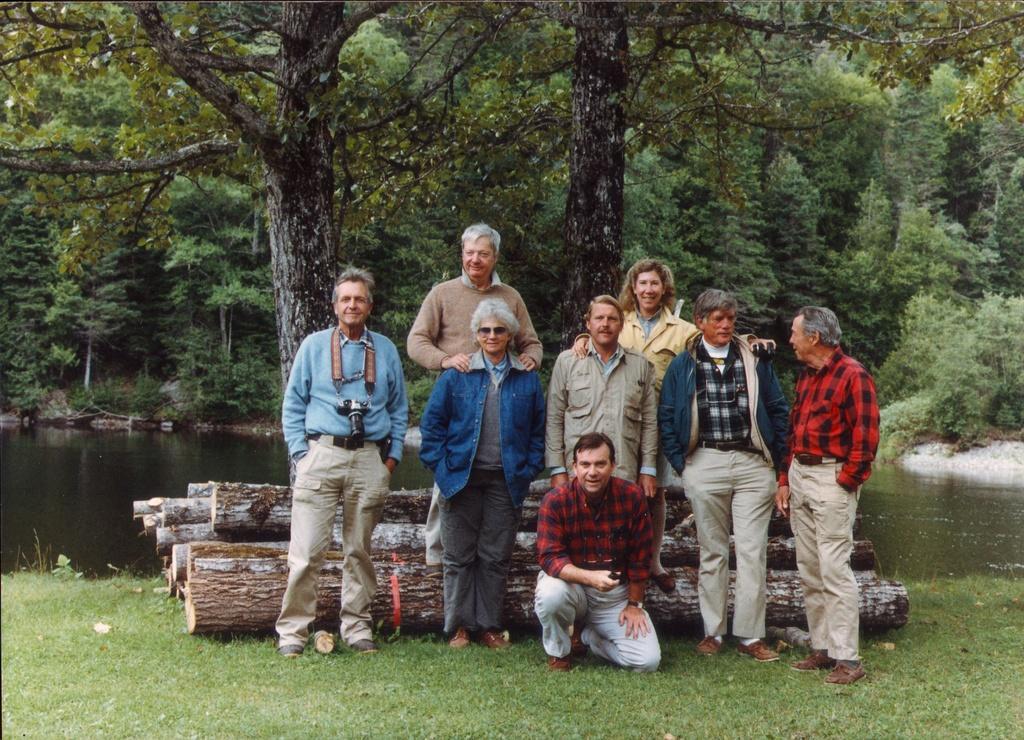Please provide a concise description of this image. In this image, we can see a group of people. Few people are watching and smiling. On the right side of the image, we can see a two person are looking at each other. At the bottom, we can see grass. Background we can see wooden logs, water, trees and plants. 